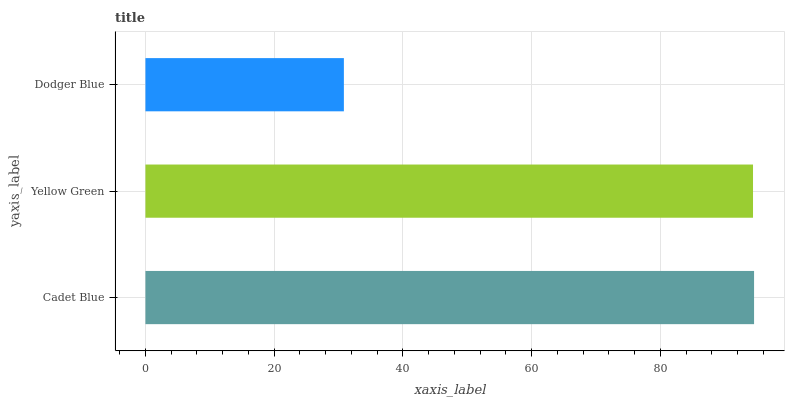Is Dodger Blue the minimum?
Answer yes or no. Yes. Is Cadet Blue the maximum?
Answer yes or no. Yes. Is Yellow Green the minimum?
Answer yes or no. No. Is Yellow Green the maximum?
Answer yes or no. No. Is Cadet Blue greater than Yellow Green?
Answer yes or no. Yes. Is Yellow Green less than Cadet Blue?
Answer yes or no. Yes. Is Yellow Green greater than Cadet Blue?
Answer yes or no. No. Is Cadet Blue less than Yellow Green?
Answer yes or no. No. Is Yellow Green the high median?
Answer yes or no. Yes. Is Yellow Green the low median?
Answer yes or no. Yes. Is Dodger Blue the high median?
Answer yes or no. No. Is Cadet Blue the low median?
Answer yes or no. No. 